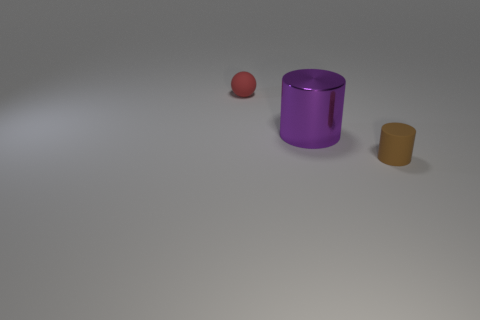What could be the function of each object in the image? Based on the image, these objects seem to be simple geometric shapes that could be used for various purposes, such as containers or educational models to demonstrate shapes and volume in a learning environment. Could these objects have symbolic meanings in a different context? Absolutely, in a different context, such as in art or literature, the red sphere could symbolize completeness or unity, while the cylinders might represent stability and strength. The arrangement of objects and their sizes could be employed to convey a particular message or theme. 